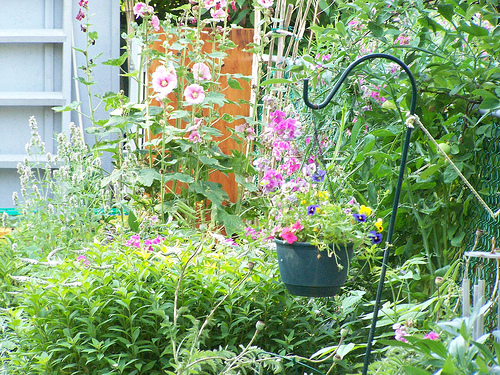<image>
Is there a pot on the bush? No. The pot is not positioned on the bush. They may be near each other, but the pot is not supported by or resting on top of the bush. 